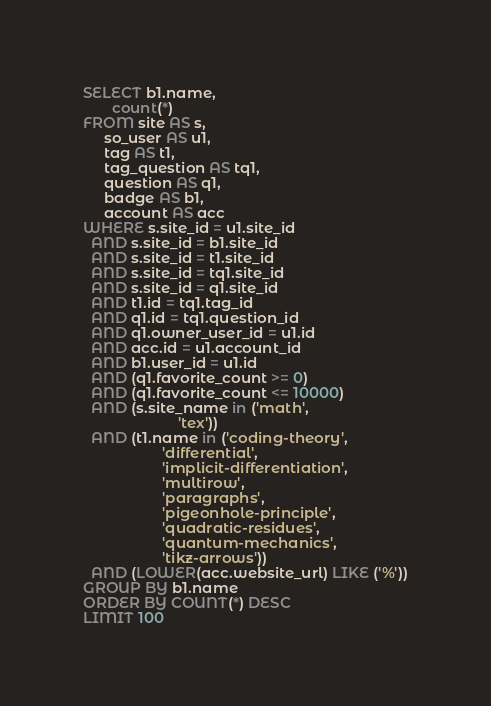<code> <loc_0><loc_0><loc_500><loc_500><_SQL_>SELECT b1.name,
       count(*)
FROM site AS s,
     so_user AS u1,
     tag AS t1,
     tag_question AS tq1,
     question AS q1,
     badge AS b1,
     account AS acc
WHERE s.site_id = u1.site_id
  AND s.site_id = b1.site_id
  AND s.site_id = t1.site_id
  AND s.site_id = tq1.site_id
  AND s.site_id = q1.site_id
  AND t1.id = tq1.tag_id
  AND q1.id = tq1.question_id
  AND q1.owner_user_id = u1.id
  AND acc.id = u1.account_id
  AND b1.user_id = u1.id
  AND (q1.favorite_count >= 0)
  AND (q1.favorite_count <= 10000)
  AND (s.site_name in ('math',
                       'tex'))
  AND (t1.name in ('coding-theory',
                   'differential',
                   'implicit-differentiation',
                   'multirow',
                   'paragraphs',
                   'pigeonhole-principle',
                   'quadratic-residues',
                   'quantum-mechanics',
                   'tikz-arrows'))
  AND (LOWER(acc.website_url) LIKE ('%'))
GROUP BY b1.name
ORDER BY COUNT(*) DESC
LIMIT 100</code> 